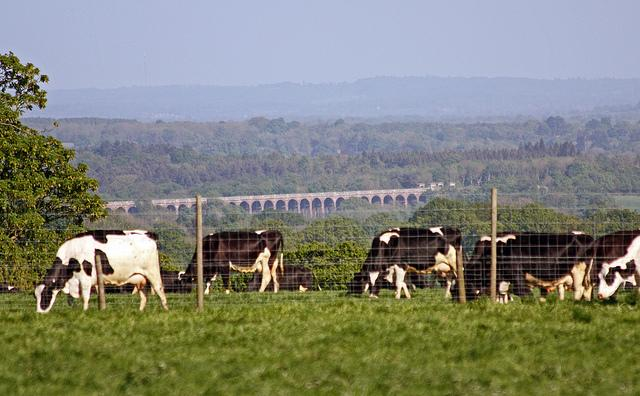The cow belongs to which genus? Please explain your reasoning. bos. The cow belongs to the genus bos. 